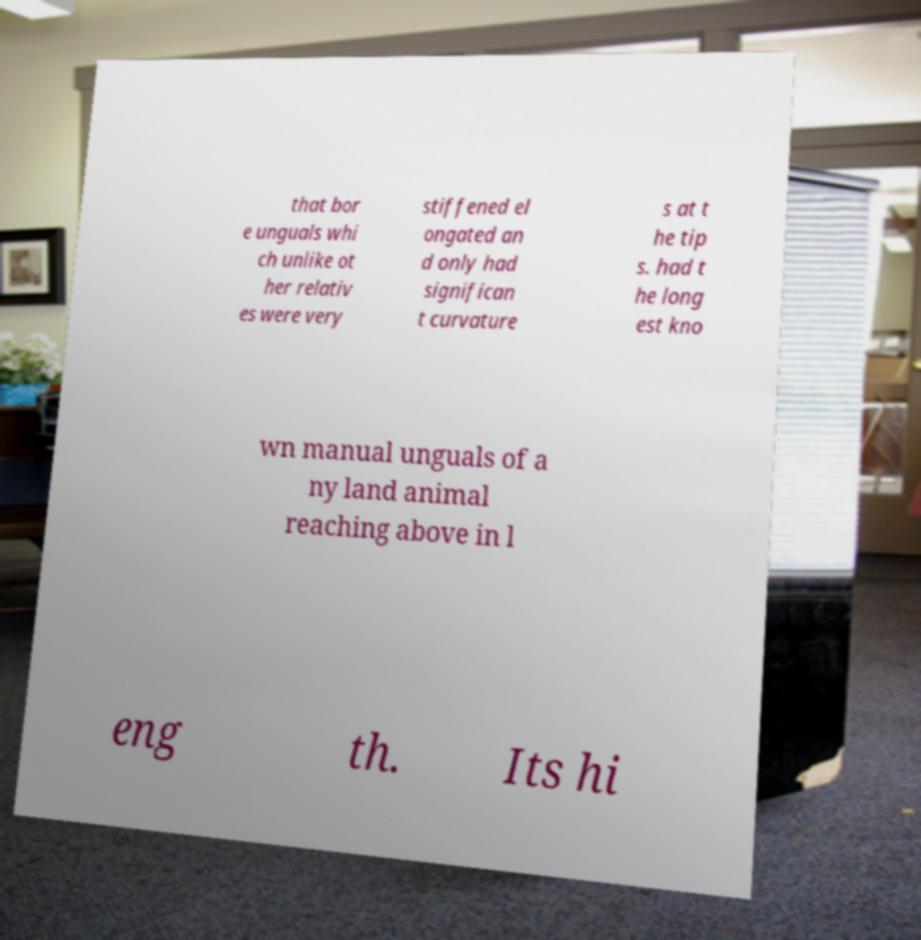Please identify and transcribe the text found in this image. that bor e unguals whi ch unlike ot her relativ es were very stiffened el ongated an d only had significan t curvature s at t he tip s. had t he long est kno wn manual unguals of a ny land animal reaching above in l eng th. Its hi 